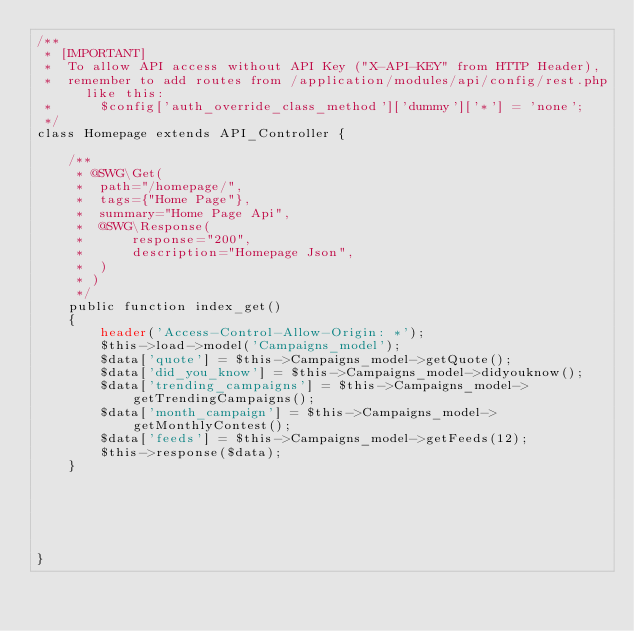<code> <loc_0><loc_0><loc_500><loc_500><_PHP_>/**
 * [IMPORTANT]
 * 	To allow API access without API Key ("X-API-KEY" from HTTP Header),
 * 	remember to add routes from /application/modules/api/config/rest.php like this:
 * 		$config['auth_override_class_method']['dummy']['*'] = 'none';
 */
class Homepage extends API_Controller {

	/**
	 * @SWG\Get(
	 * 	path="/homepage/",
	 * 	tags={"Home Page"},
	 * 	summary="Home Page Api",
	 * 	@SWG\Response(
	 * 		response="200",
	 * 		description="Homepage Json",
	 * 	)
	 * )
	 */
	public function index_get()
	{
        header('Access-Control-Allow-Origin: *');
		$this->load->model('Campaigns_model');
        $data['quote'] = $this->Campaigns_model->getQuote();
        $data['did_you_know'] = $this->Campaigns_model->didyouknow();
		$data['trending_campaigns'] = $this->Campaigns_model->getTrendingCampaigns();
        $data['month_campaign'] = $this->Campaigns_model->getMonthlyContest();
        $data['feeds'] = $this->Campaigns_model->getFeeds(12);
		$this->response($data);
	}






}
</code> 